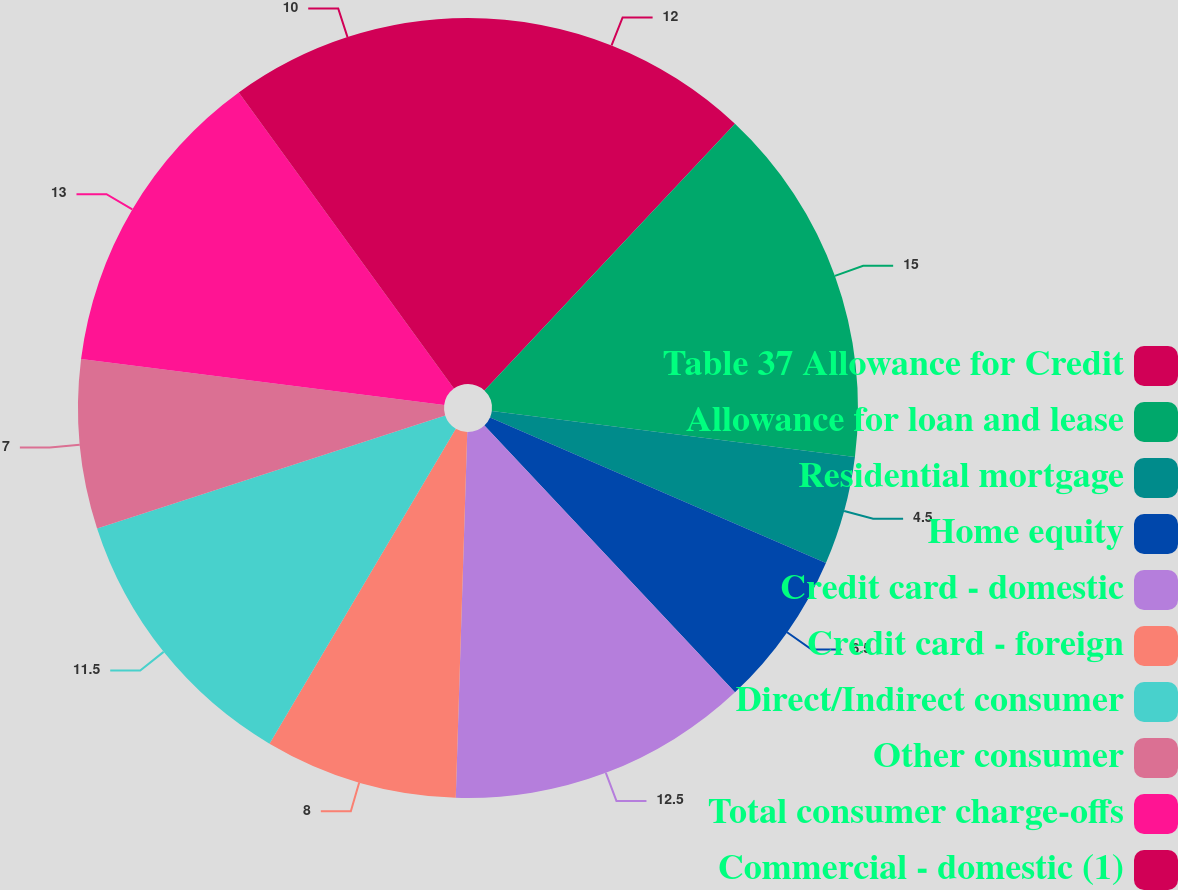Convert chart. <chart><loc_0><loc_0><loc_500><loc_500><pie_chart><fcel>Table 37 Allowance for Credit<fcel>Allowance for loan and lease<fcel>Residential mortgage<fcel>Home equity<fcel>Credit card - domestic<fcel>Credit card - foreign<fcel>Direct/Indirect consumer<fcel>Other consumer<fcel>Total consumer charge-offs<fcel>Commercial - domestic (1)<nl><fcel>12.0%<fcel>15.0%<fcel>4.5%<fcel>6.5%<fcel>12.5%<fcel>8.0%<fcel>11.5%<fcel>7.0%<fcel>13.0%<fcel>10.0%<nl></chart> 